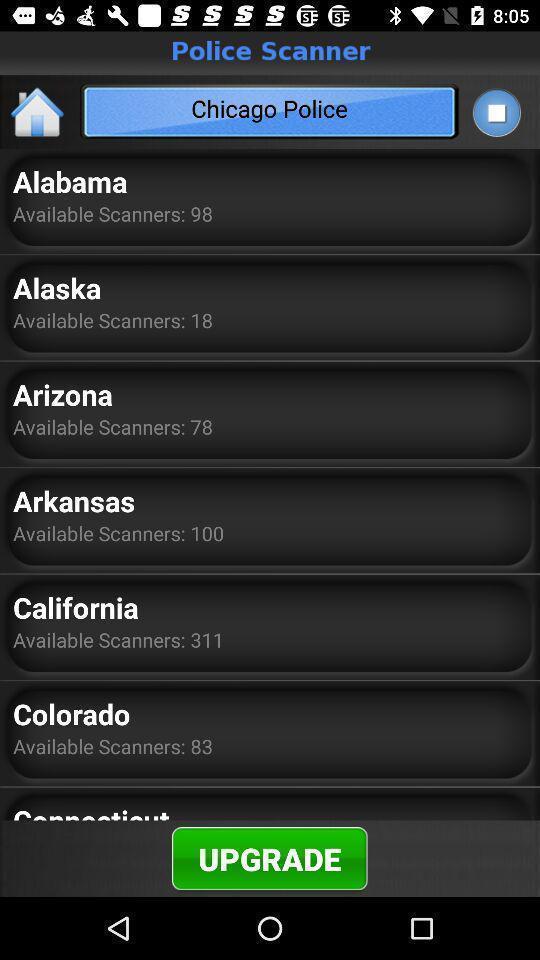Summarize the main components in this picture. Screen displaying a list of available scanners in different locations. 